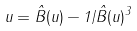<formula> <loc_0><loc_0><loc_500><loc_500>u = \hat { B } ( u ) - 1 / \hat { B } ( u ) ^ { 3 }</formula> 